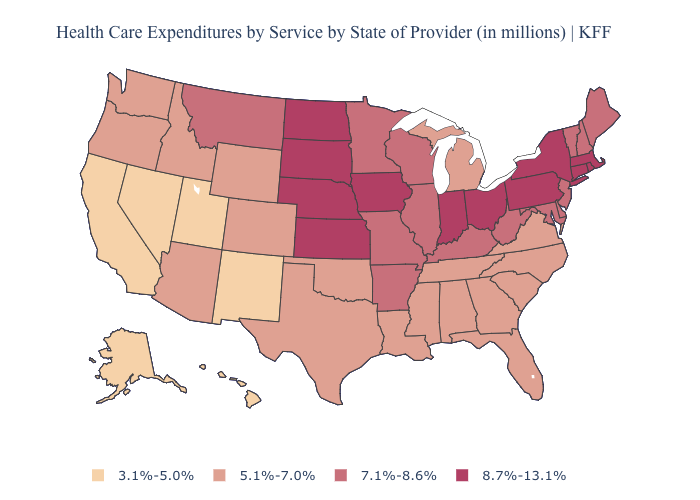How many symbols are there in the legend?
Keep it brief. 4. What is the value of South Dakota?
Quick response, please. 8.7%-13.1%. Does the map have missing data?
Answer briefly. No. Name the states that have a value in the range 8.7%-13.1%?
Answer briefly. Connecticut, Indiana, Iowa, Kansas, Massachusetts, Nebraska, New York, North Dakota, Ohio, Pennsylvania, Rhode Island, South Dakota. What is the value of Alaska?
Quick response, please. 3.1%-5.0%. What is the highest value in the MidWest ?
Give a very brief answer. 8.7%-13.1%. Does the first symbol in the legend represent the smallest category?
Short answer required. Yes. Does the map have missing data?
Keep it brief. No. Does Rhode Island have the same value as North Carolina?
Concise answer only. No. Among the states that border Virginia , which have the lowest value?
Short answer required. North Carolina, Tennessee. Name the states that have a value in the range 7.1%-8.6%?
Give a very brief answer. Arkansas, Delaware, Illinois, Kentucky, Maine, Maryland, Minnesota, Missouri, Montana, New Hampshire, New Jersey, Vermont, West Virginia, Wisconsin. Name the states that have a value in the range 7.1%-8.6%?
Write a very short answer. Arkansas, Delaware, Illinois, Kentucky, Maine, Maryland, Minnesota, Missouri, Montana, New Hampshire, New Jersey, Vermont, West Virginia, Wisconsin. Does the map have missing data?
Concise answer only. No. What is the value of Arizona?
Write a very short answer. 5.1%-7.0%. Among the states that border Georgia , which have the highest value?
Give a very brief answer. Alabama, Florida, North Carolina, South Carolina, Tennessee. 